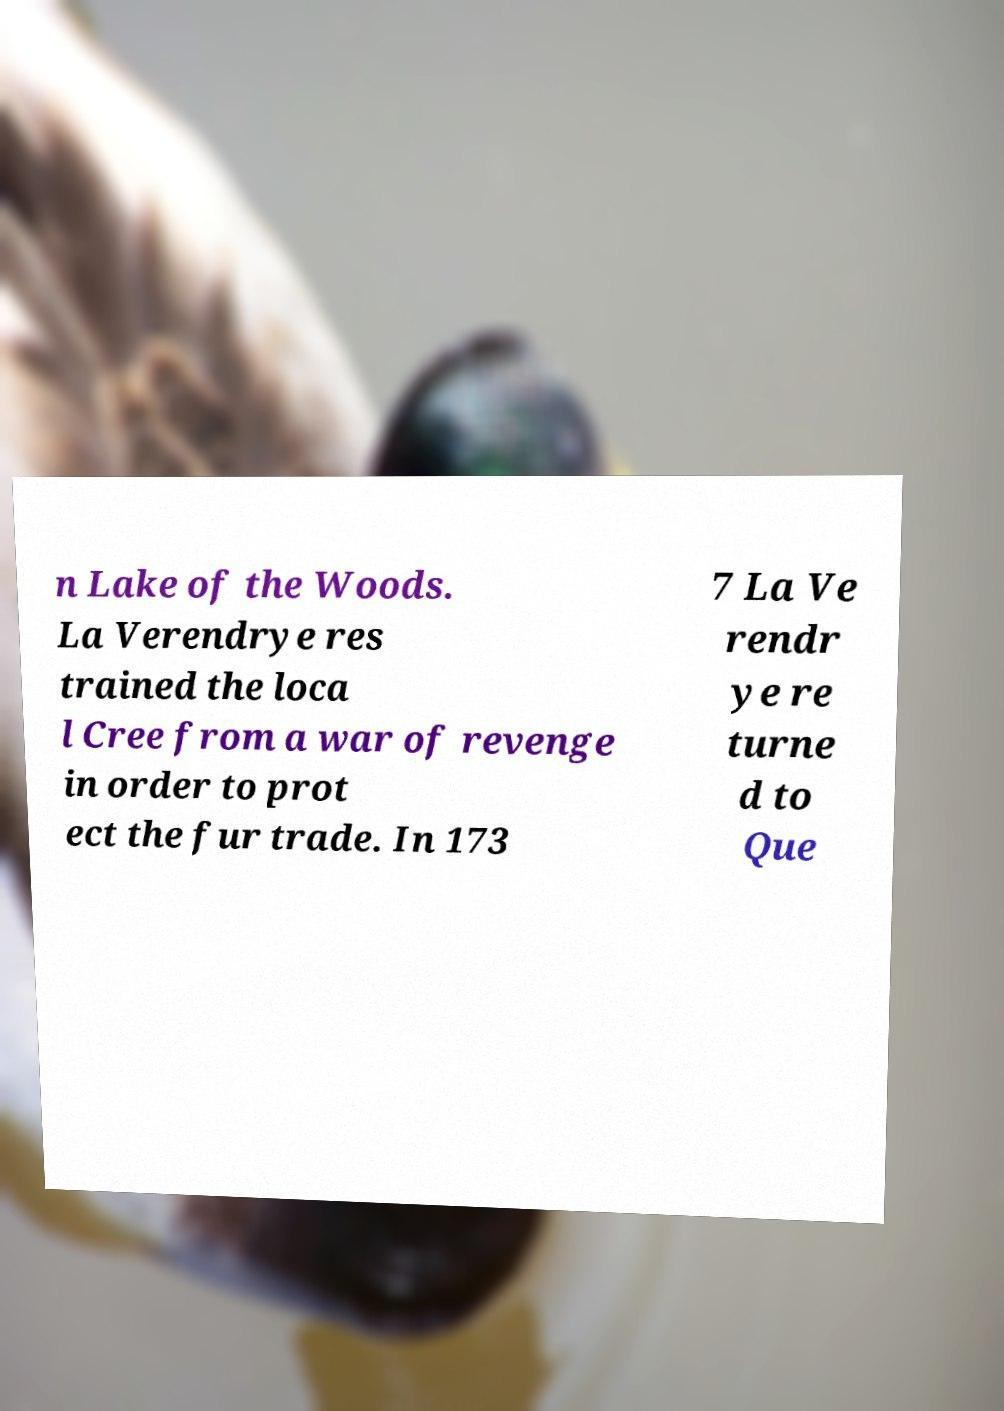For documentation purposes, I need the text within this image transcribed. Could you provide that? n Lake of the Woods. La Verendrye res trained the loca l Cree from a war of revenge in order to prot ect the fur trade. In 173 7 La Ve rendr ye re turne d to Que 